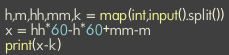Convert code to text. <code><loc_0><loc_0><loc_500><loc_500><_Python_>h,m,hh,mm,k = map(int,input().split())
x = hh*60-h*60+mm-m
print(x-k)</code> 